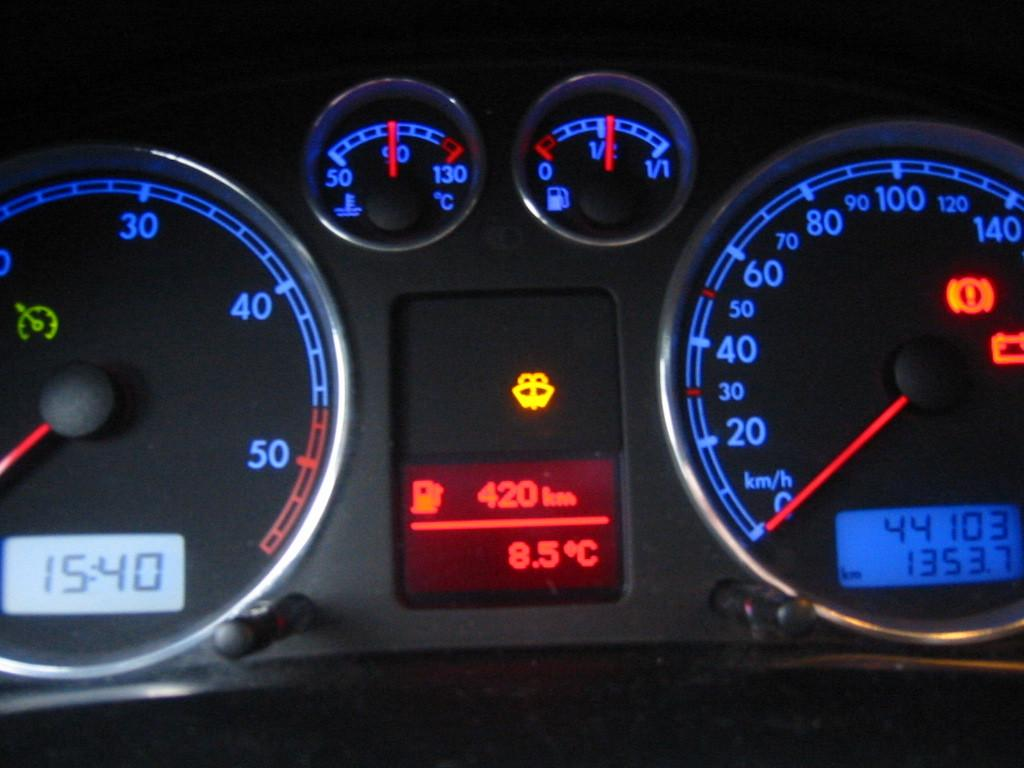What is the main object in the image? There is a speedometer in the image. What feature does the speedometer have? The speedometer has numbers on it. Can you see any worms crawling on the speedometer in the image? There are no worms present in the image, as it features a speedometer with numbers on it. 